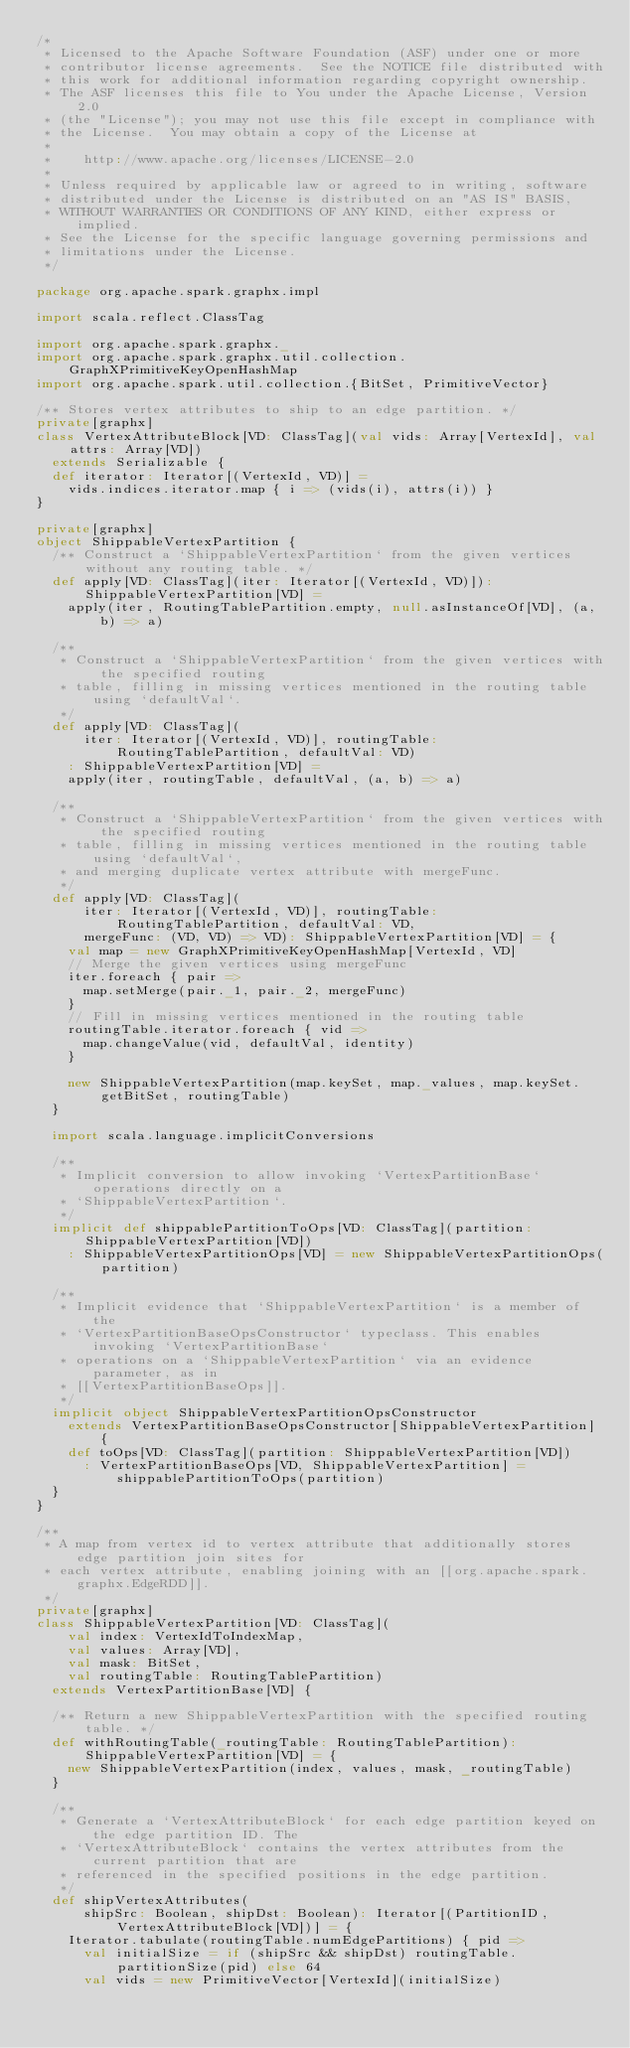<code> <loc_0><loc_0><loc_500><loc_500><_Scala_>/*
 * Licensed to the Apache Software Foundation (ASF) under one or more
 * contributor license agreements.  See the NOTICE file distributed with
 * this work for additional information regarding copyright ownership.
 * The ASF licenses this file to You under the Apache License, Version 2.0
 * (the "License"); you may not use this file except in compliance with
 * the License.  You may obtain a copy of the License at
 *
 *    http://www.apache.org/licenses/LICENSE-2.0
 *
 * Unless required by applicable law or agreed to in writing, software
 * distributed under the License is distributed on an "AS IS" BASIS,
 * WITHOUT WARRANTIES OR CONDITIONS OF ANY KIND, either express or implied.
 * See the License for the specific language governing permissions and
 * limitations under the License.
 */

package org.apache.spark.graphx.impl

import scala.reflect.ClassTag

import org.apache.spark.graphx._
import org.apache.spark.graphx.util.collection.GraphXPrimitiveKeyOpenHashMap
import org.apache.spark.util.collection.{BitSet, PrimitiveVector}

/** Stores vertex attributes to ship to an edge partition. */
private[graphx]
class VertexAttributeBlock[VD: ClassTag](val vids: Array[VertexId], val attrs: Array[VD])
  extends Serializable {
  def iterator: Iterator[(VertexId, VD)] =
    vids.indices.iterator.map { i => (vids(i), attrs(i)) }
}

private[graphx]
object ShippableVertexPartition {
  /** Construct a `ShippableVertexPartition` from the given vertices without any routing table. */
  def apply[VD: ClassTag](iter: Iterator[(VertexId, VD)]): ShippableVertexPartition[VD] =
    apply(iter, RoutingTablePartition.empty, null.asInstanceOf[VD], (a, b) => a)

  /**
   * Construct a `ShippableVertexPartition` from the given vertices with the specified routing
   * table, filling in missing vertices mentioned in the routing table using `defaultVal`.
   */
  def apply[VD: ClassTag](
      iter: Iterator[(VertexId, VD)], routingTable: RoutingTablePartition, defaultVal: VD)
    : ShippableVertexPartition[VD] =
    apply(iter, routingTable, defaultVal, (a, b) => a)

  /**
   * Construct a `ShippableVertexPartition` from the given vertices with the specified routing
   * table, filling in missing vertices mentioned in the routing table using `defaultVal`,
   * and merging duplicate vertex attribute with mergeFunc.
   */
  def apply[VD: ClassTag](
      iter: Iterator[(VertexId, VD)], routingTable: RoutingTablePartition, defaultVal: VD,
      mergeFunc: (VD, VD) => VD): ShippableVertexPartition[VD] = {
    val map = new GraphXPrimitiveKeyOpenHashMap[VertexId, VD]
    // Merge the given vertices using mergeFunc
    iter.foreach { pair =>
      map.setMerge(pair._1, pair._2, mergeFunc)
    }
    // Fill in missing vertices mentioned in the routing table
    routingTable.iterator.foreach { vid =>
      map.changeValue(vid, defaultVal, identity)
    }

    new ShippableVertexPartition(map.keySet, map._values, map.keySet.getBitSet, routingTable)
  }

  import scala.language.implicitConversions

  /**
   * Implicit conversion to allow invoking `VertexPartitionBase` operations directly on a
   * `ShippableVertexPartition`.
   */
  implicit def shippablePartitionToOps[VD: ClassTag](partition: ShippableVertexPartition[VD])
    : ShippableVertexPartitionOps[VD] = new ShippableVertexPartitionOps(partition)

  /**
   * Implicit evidence that `ShippableVertexPartition` is a member of the
   * `VertexPartitionBaseOpsConstructor` typeclass. This enables invoking `VertexPartitionBase`
   * operations on a `ShippableVertexPartition` via an evidence parameter, as in
   * [[VertexPartitionBaseOps]].
   */
  implicit object ShippableVertexPartitionOpsConstructor
    extends VertexPartitionBaseOpsConstructor[ShippableVertexPartition] {
    def toOps[VD: ClassTag](partition: ShippableVertexPartition[VD])
      : VertexPartitionBaseOps[VD, ShippableVertexPartition] = shippablePartitionToOps(partition)
  }
}

/**
 * A map from vertex id to vertex attribute that additionally stores edge partition join sites for
 * each vertex attribute, enabling joining with an [[org.apache.spark.graphx.EdgeRDD]].
 */
private[graphx]
class ShippableVertexPartition[VD: ClassTag](
    val index: VertexIdToIndexMap,
    val values: Array[VD],
    val mask: BitSet,
    val routingTable: RoutingTablePartition)
  extends VertexPartitionBase[VD] {

  /** Return a new ShippableVertexPartition with the specified routing table. */
  def withRoutingTable(_routingTable: RoutingTablePartition): ShippableVertexPartition[VD] = {
    new ShippableVertexPartition(index, values, mask, _routingTable)
  }

  /**
   * Generate a `VertexAttributeBlock` for each edge partition keyed on the edge partition ID. The
   * `VertexAttributeBlock` contains the vertex attributes from the current partition that are
   * referenced in the specified positions in the edge partition.
   */
  def shipVertexAttributes(
      shipSrc: Boolean, shipDst: Boolean): Iterator[(PartitionID, VertexAttributeBlock[VD])] = {
    Iterator.tabulate(routingTable.numEdgePartitions) { pid =>
      val initialSize = if (shipSrc && shipDst) routingTable.partitionSize(pid) else 64
      val vids = new PrimitiveVector[VertexId](initialSize)</code> 